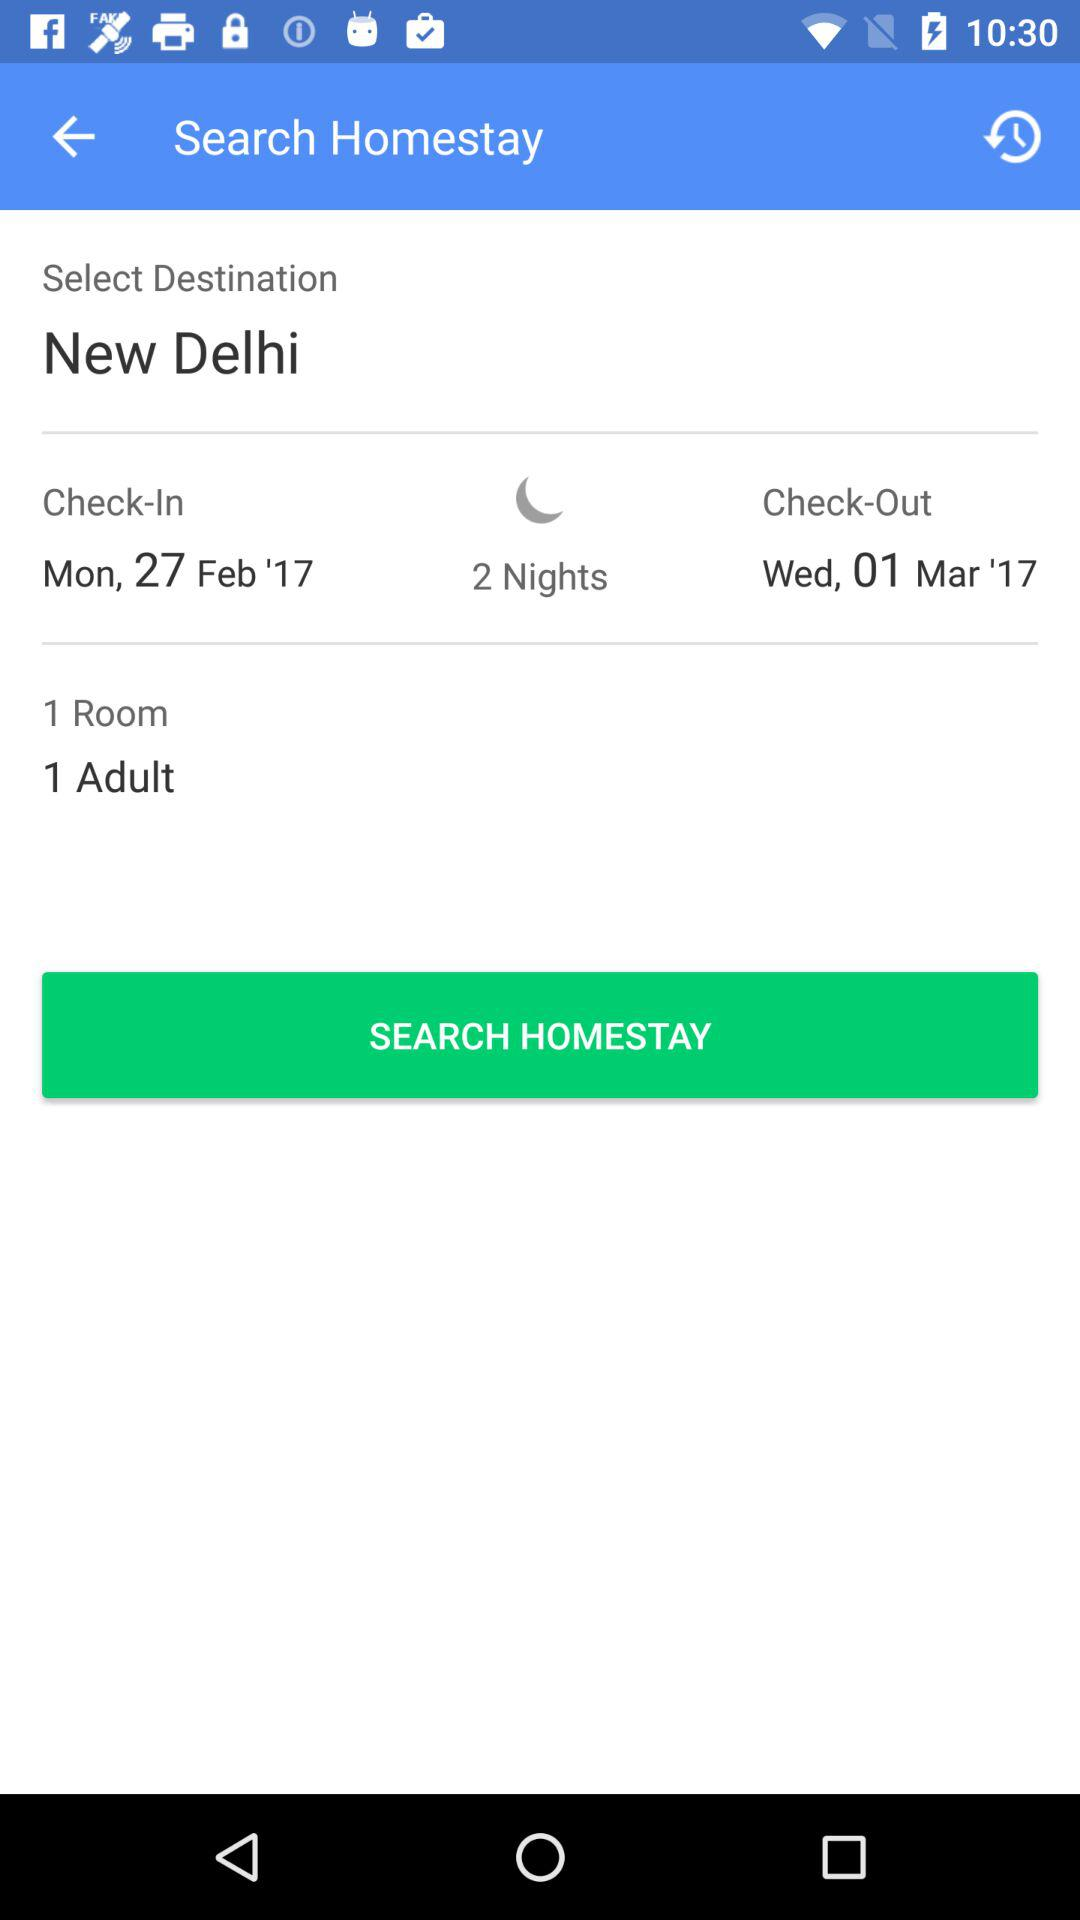How many adults are there? There is 1 adult. 